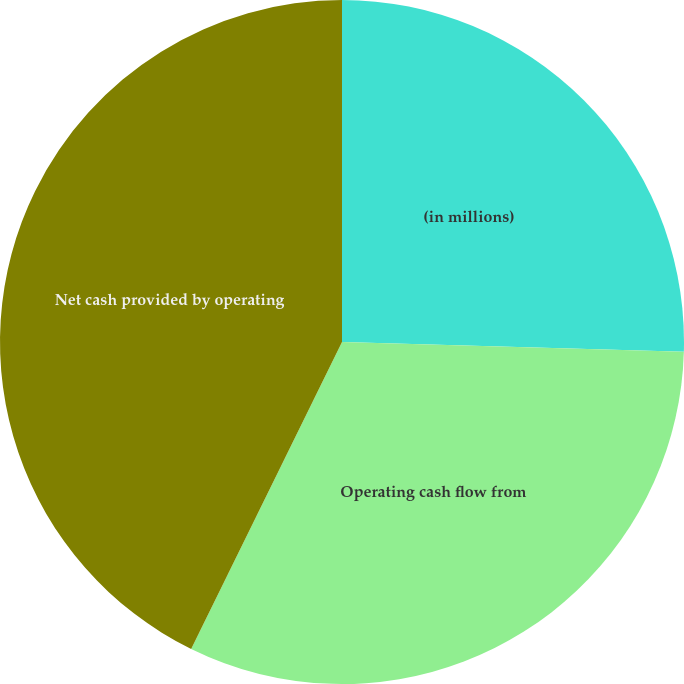Convert chart to OTSL. <chart><loc_0><loc_0><loc_500><loc_500><pie_chart><fcel>(in millions)<fcel>Operating cash flow from<fcel>Net cash provided by operating<nl><fcel>25.45%<fcel>31.82%<fcel>42.73%<nl></chart> 